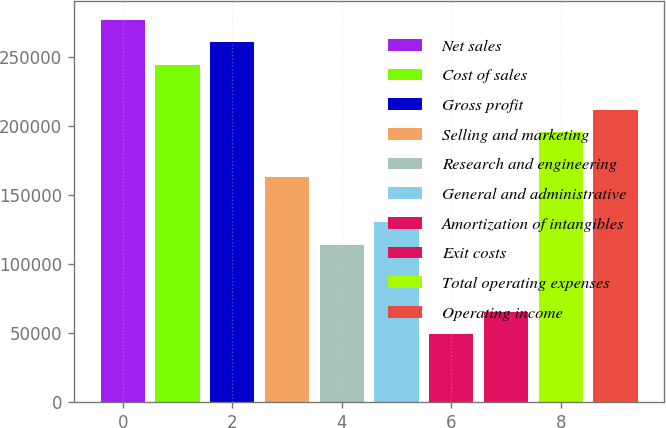<chart> <loc_0><loc_0><loc_500><loc_500><bar_chart><fcel>Net sales<fcel>Cost of sales<fcel>Gross profit<fcel>Selling and marketing<fcel>Research and engineering<fcel>General and administrative<fcel>Amortization of intangibles<fcel>Exit costs<fcel>Total operating expenses<fcel>Operating income<nl><fcel>276807<fcel>244242<fcel>260524<fcel>162830<fcel>113983<fcel>130265<fcel>48853.2<fcel>65135.6<fcel>195395<fcel>211677<nl></chart> 